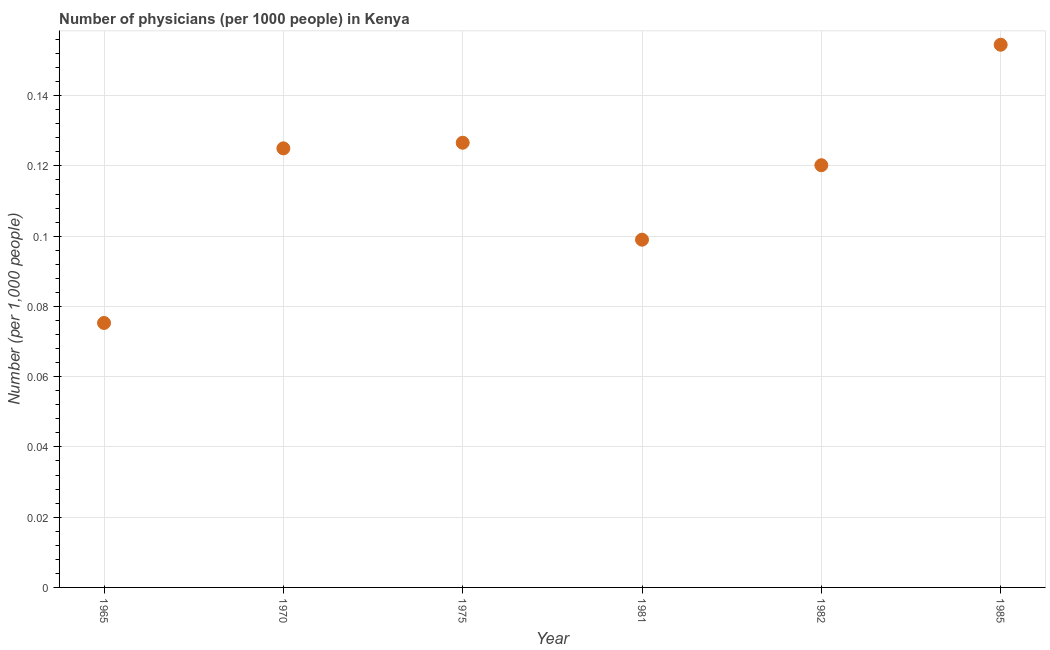What is the number of physicians in 1981?
Keep it short and to the point. 0.1. Across all years, what is the maximum number of physicians?
Offer a terse response. 0.15. Across all years, what is the minimum number of physicians?
Give a very brief answer. 0.08. In which year was the number of physicians minimum?
Offer a terse response. 1965. What is the sum of the number of physicians?
Your answer should be very brief. 0.7. What is the difference between the number of physicians in 1970 and 1981?
Your answer should be very brief. 0.03. What is the average number of physicians per year?
Your answer should be compact. 0.12. What is the median number of physicians?
Make the answer very short. 0.12. What is the ratio of the number of physicians in 1975 to that in 1985?
Keep it short and to the point. 0.82. Is the difference between the number of physicians in 1965 and 1985 greater than the difference between any two years?
Make the answer very short. Yes. What is the difference between the highest and the second highest number of physicians?
Your answer should be compact. 0.03. Is the sum of the number of physicians in 1975 and 1985 greater than the maximum number of physicians across all years?
Your answer should be compact. Yes. What is the difference between the highest and the lowest number of physicians?
Offer a terse response. 0.08. In how many years, is the number of physicians greater than the average number of physicians taken over all years?
Ensure brevity in your answer.  4. Are the values on the major ticks of Y-axis written in scientific E-notation?
Your answer should be very brief. No. Does the graph contain any zero values?
Give a very brief answer. No. What is the title of the graph?
Your answer should be very brief. Number of physicians (per 1000 people) in Kenya. What is the label or title of the X-axis?
Your answer should be compact. Year. What is the label or title of the Y-axis?
Make the answer very short. Number (per 1,0 people). What is the Number (per 1,000 people) in 1965?
Your response must be concise. 0.08. What is the Number (per 1,000 people) in 1970?
Your response must be concise. 0.12. What is the Number (per 1,000 people) in 1975?
Your answer should be very brief. 0.13. What is the Number (per 1,000 people) in 1981?
Your answer should be very brief. 0.1. What is the Number (per 1,000 people) in 1982?
Provide a succinct answer. 0.12. What is the Number (per 1,000 people) in 1985?
Your answer should be compact. 0.15. What is the difference between the Number (per 1,000 people) in 1965 and 1970?
Ensure brevity in your answer.  -0.05. What is the difference between the Number (per 1,000 people) in 1965 and 1975?
Provide a succinct answer. -0.05. What is the difference between the Number (per 1,000 people) in 1965 and 1981?
Provide a succinct answer. -0.02. What is the difference between the Number (per 1,000 people) in 1965 and 1982?
Ensure brevity in your answer.  -0.04. What is the difference between the Number (per 1,000 people) in 1965 and 1985?
Your answer should be very brief. -0.08. What is the difference between the Number (per 1,000 people) in 1970 and 1975?
Give a very brief answer. -0. What is the difference between the Number (per 1,000 people) in 1970 and 1981?
Provide a succinct answer. 0.03. What is the difference between the Number (per 1,000 people) in 1970 and 1982?
Provide a succinct answer. 0. What is the difference between the Number (per 1,000 people) in 1970 and 1985?
Your answer should be very brief. -0.03. What is the difference between the Number (per 1,000 people) in 1975 and 1981?
Your answer should be compact. 0.03. What is the difference between the Number (per 1,000 people) in 1975 and 1982?
Make the answer very short. 0.01. What is the difference between the Number (per 1,000 people) in 1975 and 1985?
Your answer should be very brief. -0.03. What is the difference between the Number (per 1,000 people) in 1981 and 1982?
Keep it short and to the point. -0.02. What is the difference between the Number (per 1,000 people) in 1981 and 1985?
Keep it short and to the point. -0.06. What is the difference between the Number (per 1,000 people) in 1982 and 1985?
Provide a short and direct response. -0.03. What is the ratio of the Number (per 1,000 people) in 1965 to that in 1970?
Keep it short and to the point. 0.6. What is the ratio of the Number (per 1,000 people) in 1965 to that in 1975?
Your answer should be very brief. 0.59. What is the ratio of the Number (per 1,000 people) in 1965 to that in 1981?
Provide a succinct answer. 0.76. What is the ratio of the Number (per 1,000 people) in 1965 to that in 1982?
Ensure brevity in your answer.  0.63. What is the ratio of the Number (per 1,000 people) in 1965 to that in 1985?
Offer a very short reply. 0.49. What is the ratio of the Number (per 1,000 people) in 1970 to that in 1975?
Offer a very short reply. 0.99. What is the ratio of the Number (per 1,000 people) in 1970 to that in 1981?
Your response must be concise. 1.26. What is the ratio of the Number (per 1,000 people) in 1970 to that in 1985?
Your response must be concise. 0.81. What is the ratio of the Number (per 1,000 people) in 1975 to that in 1981?
Ensure brevity in your answer.  1.28. What is the ratio of the Number (per 1,000 people) in 1975 to that in 1982?
Offer a very short reply. 1.05. What is the ratio of the Number (per 1,000 people) in 1975 to that in 1985?
Offer a terse response. 0.82. What is the ratio of the Number (per 1,000 people) in 1981 to that in 1982?
Ensure brevity in your answer.  0.82. What is the ratio of the Number (per 1,000 people) in 1981 to that in 1985?
Provide a short and direct response. 0.64. What is the ratio of the Number (per 1,000 people) in 1982 to that in 1985?
Offer a terse response. 0.78. 